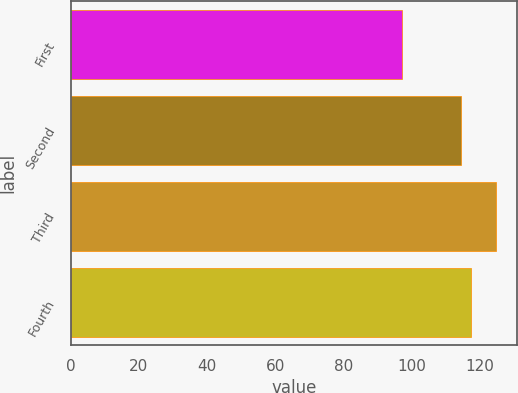<chart> <loc_0><loc_0><loc_500><loc_500><bar_chart><fcel>First<fcel>Second<fcel>Third<fcel>Fourth<nl><fcel>97.24<fcel>114.65<fcel>124.77<fcel>117.4<nl></chart> 